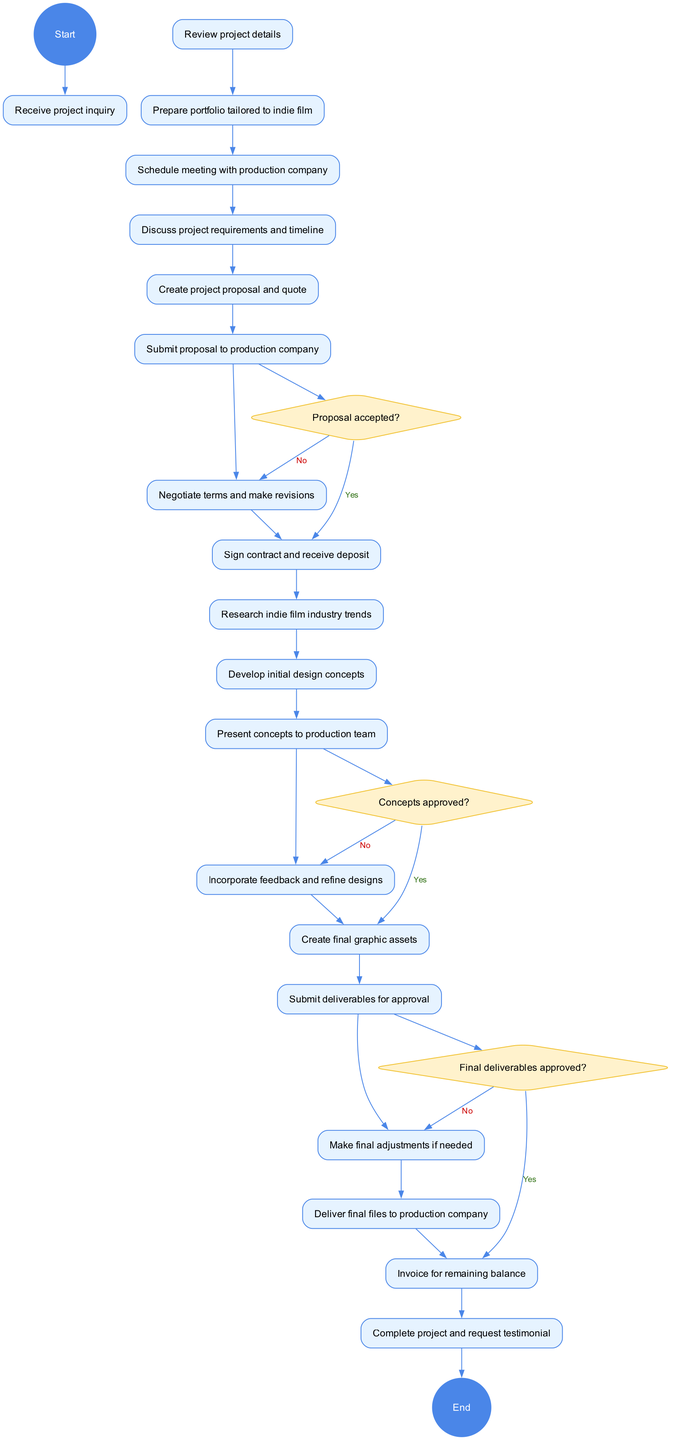What is the starting node of the diagram? The starting node is labeled "Receive project inquiry," which is the first activity shown in the diagram before any other activities take place.
Answer: Receive project inquiry How many decision points are in the diagram? The diagram contains three decision points, as indicated by the three questions: "Proposal accepted?", "Concepts approved?", and "Final deliverables approved?".
Answer: 3 What happens if the proposal is not accepted? If the proposal is not accepted, the next step is to "Negotiate terms and make revisions", indicating that the process involves further discussions before moving forward.
Answer: Negotiate terms and make revisions What is the last activity before the project completion? The last activity before completing the project is "Deliver final files to production company," which is the final substantive task before the project is considered complete.
Answer: Deliver final files to production company What is the outcome if the final deliverables are not approved? If the final deliverables are not approved, it leads to "Make final adjustments if needed," showing that there's a need for revisions before the project can be finalized.
Answer: Make final adjustments if needed Which activity follows "Incorporate feedback and refine designs"? The activity that follows "Incorporate feedback and refine designs" is "Create final graphic assets," indicating the progress towards finalizing the project after receiving feedback.
Answer: Create final graphic assets What is the last node of the diagram? The last node in the diagram is "Complete project and request testimonial," marking the final step of the project workflow after all tasks and approvals.
Answer: Complete project and request testimonial What activity comes after "Submit proposal to production company"? After submitting the proposal, the next activity is "Negotiate terms and make revisions," outlining that discussions on the proposal terms are the next step.
Answer: Negotiate terms and make revisions 